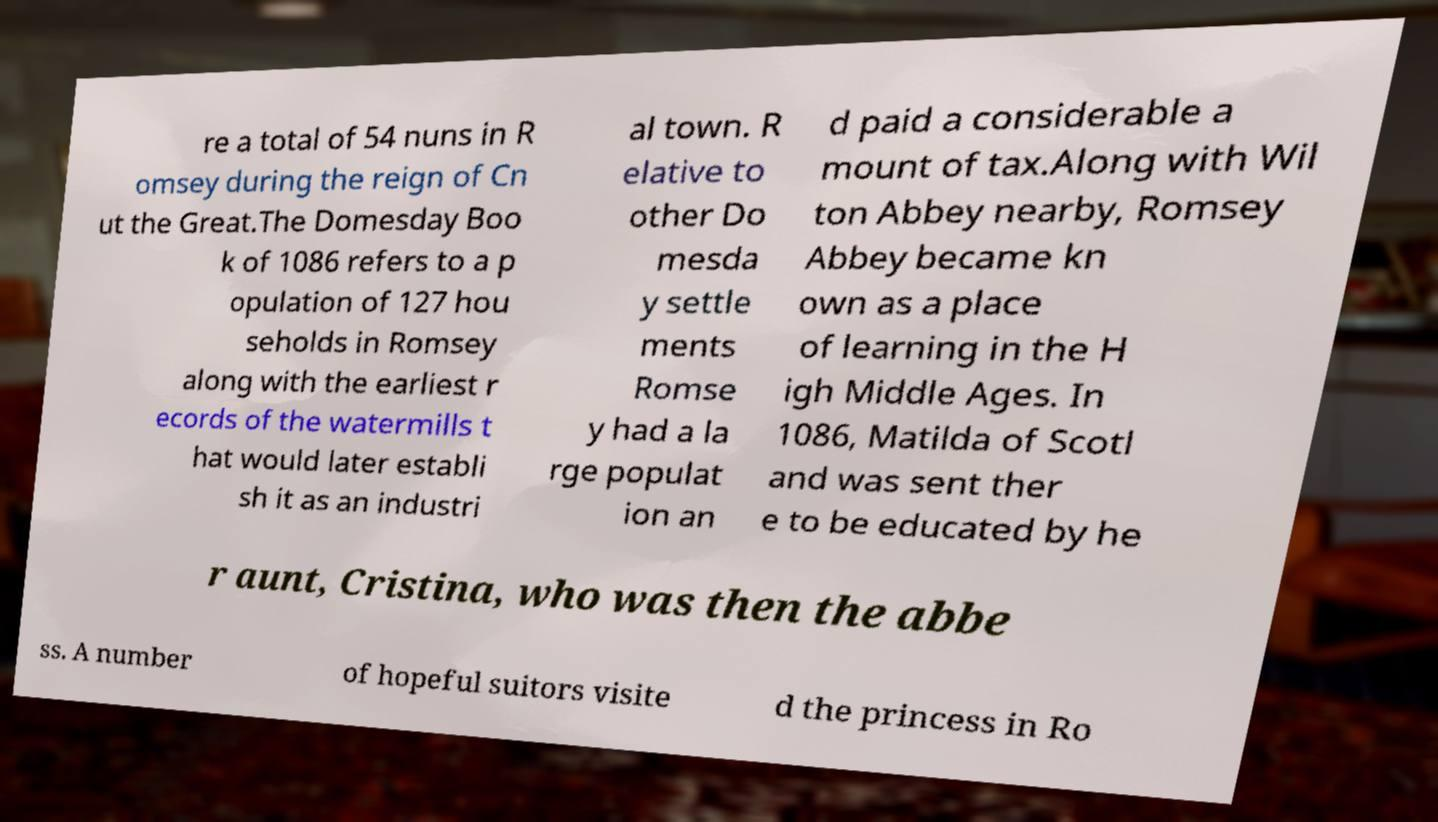Please read and relay the text visible in this image. What does it say? re a total of 54 nuns in R omsey during the reign of Cn ut the Great.The Domesday Boo k of 1086 refers to a p opulation of 127 hou seholds in Romsey along with the earliest r ecords of the watermills t hat would later establi sh it as an industri al town. R elative to other Do mesda y settle ments Romse y had a la rge populat ion an d paid a considerable a mount of tax.Along with Wil ton Abbey nearby, Romsey Abbey became kn own as a place of learning in the H igh Middle Ages. In 1086, Matilda of Scotl and was sent ther e to be educated by he r aunt, Cristina, who was then the abbe ss. A number of hopeful suitors visite d the princess in Ro 